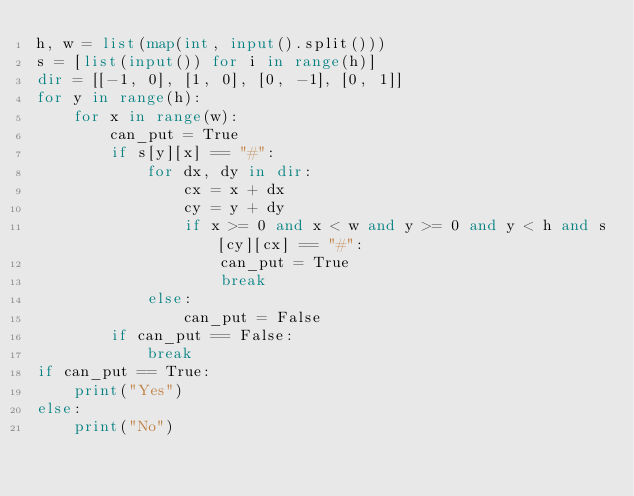Convert code to text. <code><loc_0><loc_0><loc_500><loc_500><_Python_>h, w = list(map(int, input().split()))
s = [list(input()) for i in range(h)]
dir = [[-1, 0], [1, 0], [0, -1], [0, 1]]
for y in range(h):
    for x in range(w):
        can_put = True
        if s[y][x] == "#":
            for dx, dy in dir:
                cx = x + dx
                cy = y + dy
                if x >= 0 and x < w and y >= 0 and y < h and s[cy][cx] == "#":
                    can_put = True
                    break
            else:
                can_put = False
        if can_put == False:
            break
if can_put == True:
    print("Yes")
else:
    print("No")
</code> 